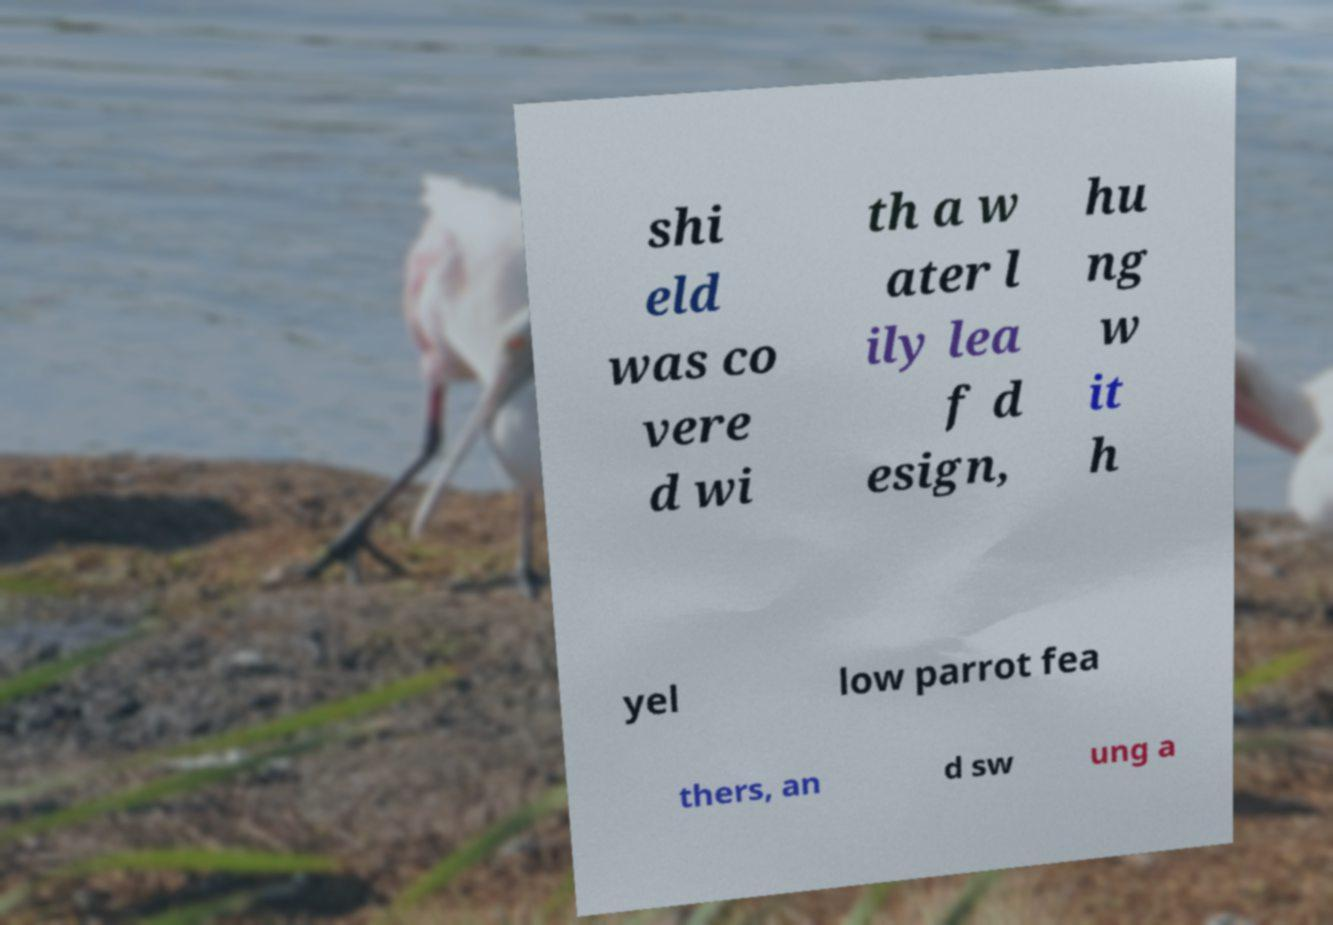Can you accurately transcribe the text from the provided image for me? shi eld was co vere d wi th a w ater l ily lea f d esign, hu ng w it h yel low parrot fea thers, an d sw ung a 